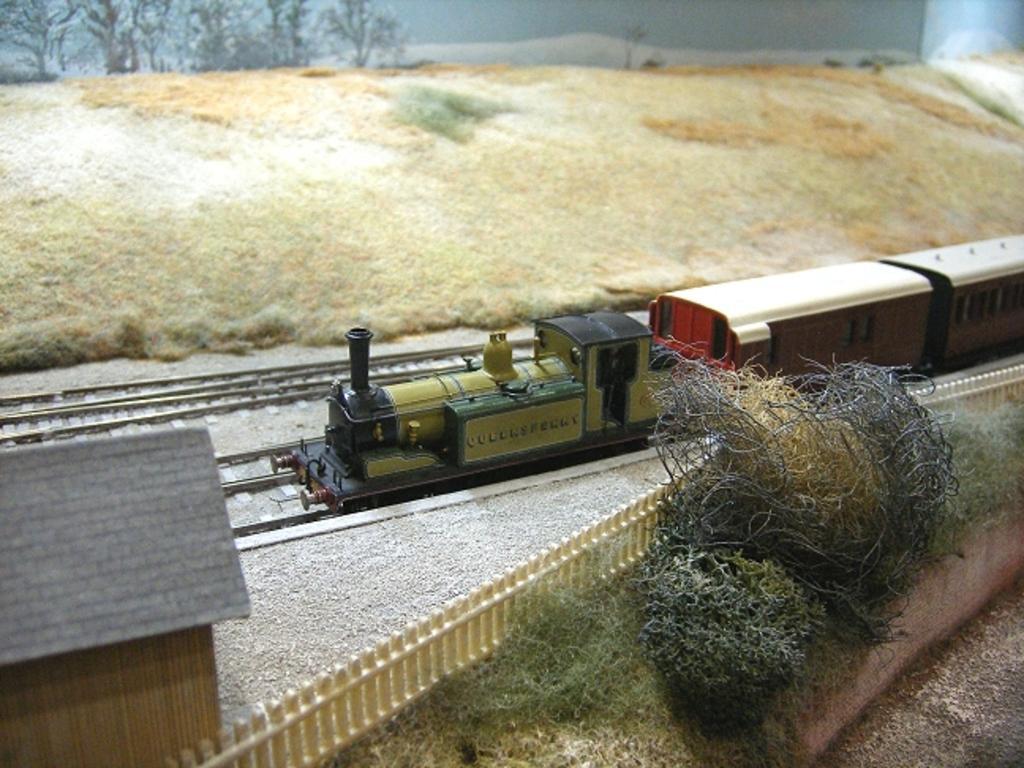Describe this image in one or two sentences. In this image there are toys. In the center there is a toy train moving on the tracks. Beside the train there is a wooden fencing. Behind the fencing there are plants and grass on the ground. In the bottom left there is a toy house. On the other side of the train there is a hill. In the background there are trees. 